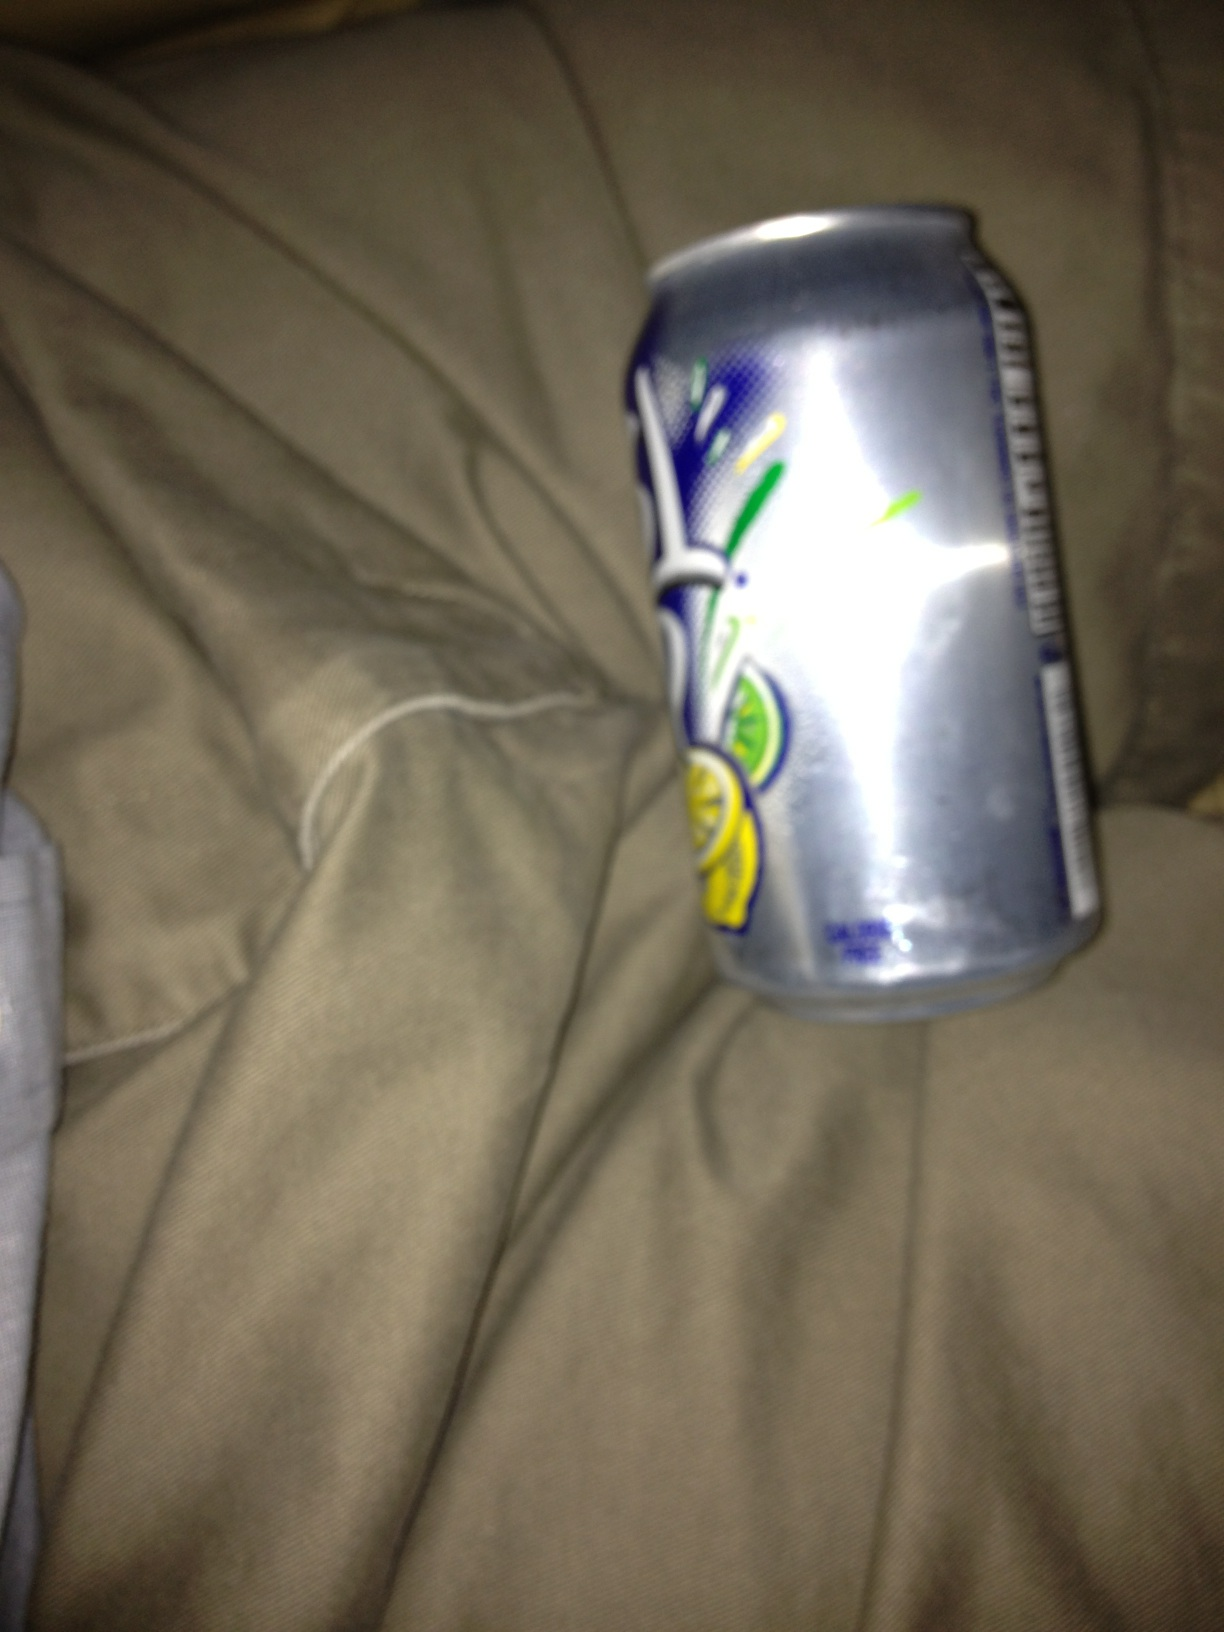Can you describe the condition of the item in this image? The item in the image, a can of Sprite, appears to be crumpled and possibly discarded. The condition suggests it was squeezed in the middle, deforming its original cylindrical shape. Why do you think it ended up in this condition? The can may have been crumpled as a result of being discarded after use. People sometimes crush cans before disposing of them to save space in recycling bins. 